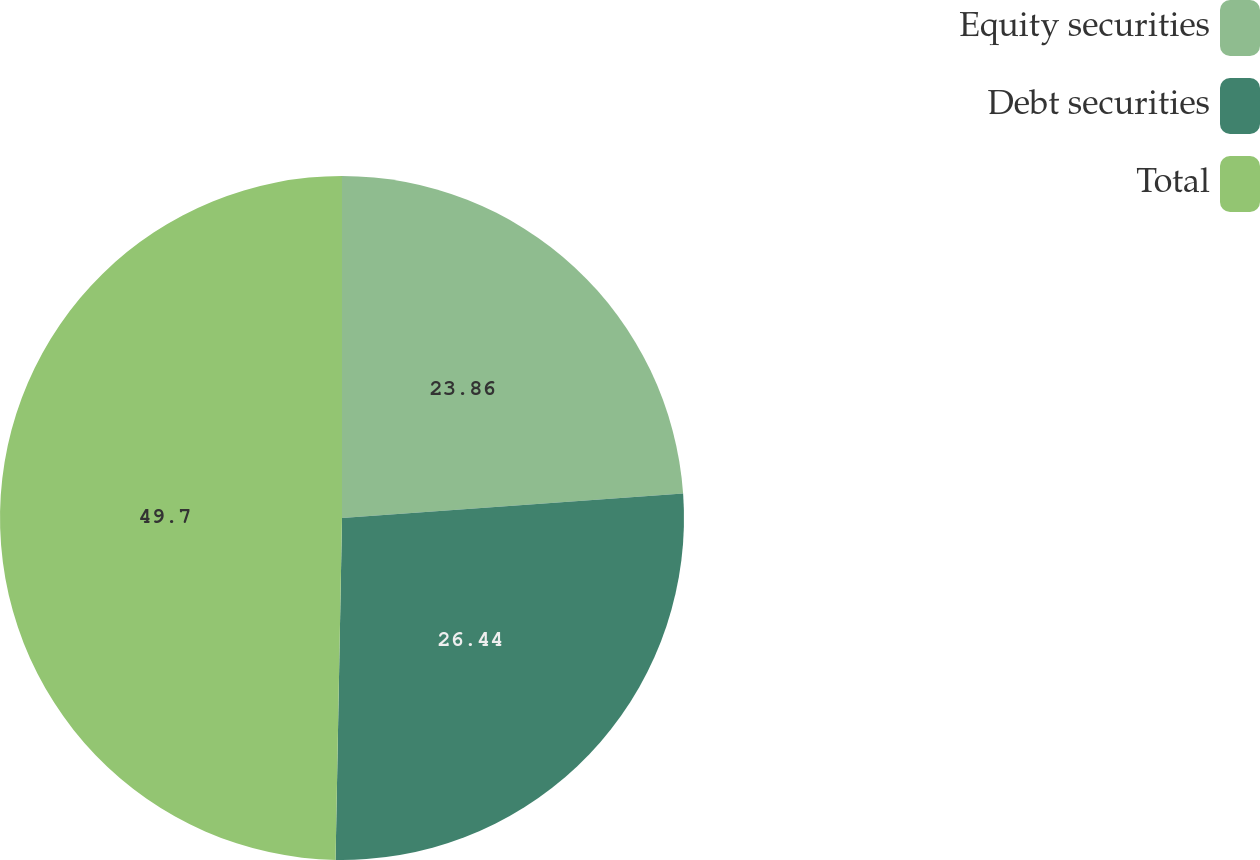Convert chart to OTSL. <chart><loc_0><loc_0><loc_500><loc_500><pie_chart><fcel>Equity securities<fcel>Debt securities<fcel>Total<nl><fcel>23.86%<fcel>26.44%<fcel>49.7%<nl></chart> 